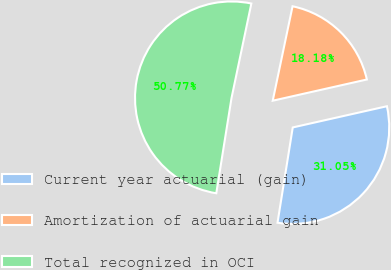Convert chart. <chart><loc_0><loc_0><loc_500><loc_500><pie_chart><fcel>Current year actuarial (gain)<fcel>Amortization of actuarial gain<fcel>Total recognized in OCI<nl><fcel>31.05%<fcel>18.18%<fcel>50.77%<nl></chart> 